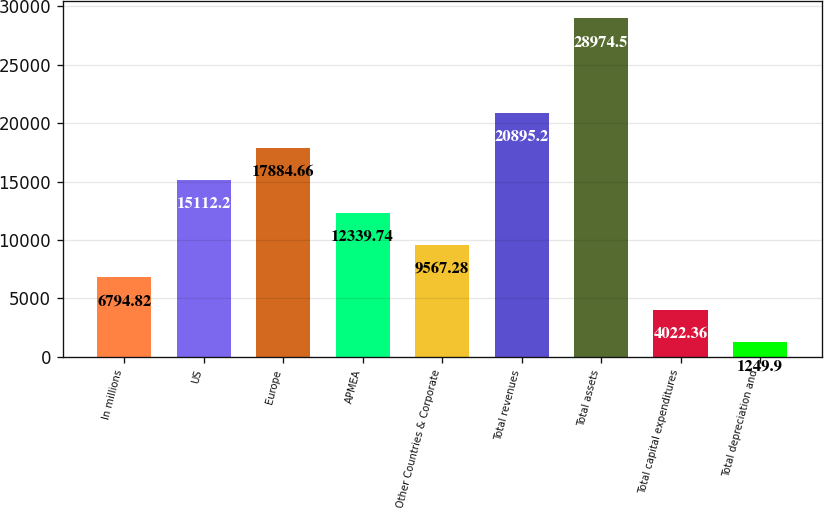Convert chart to OTSL. <chart><loc_0><loc_0><loc_500><loc_500><bar_chart><fcel>In millions<fcel>US<fcel>Europe<fcel>APMEA<fcel>Other Countries & Corporate<fcel>Total revenues<fcel>Total assets<fcel>Total capital expenditures<fcel>Total depreciation and<nl><fcel>6794.82<fcel>15112.2<fcel>17884.7<fcel>12339.7<fcel>9567.28<fcel>20895.2<fcel>28974.5<fcel>4022.36<fcel>1249.9<nl></chart> 